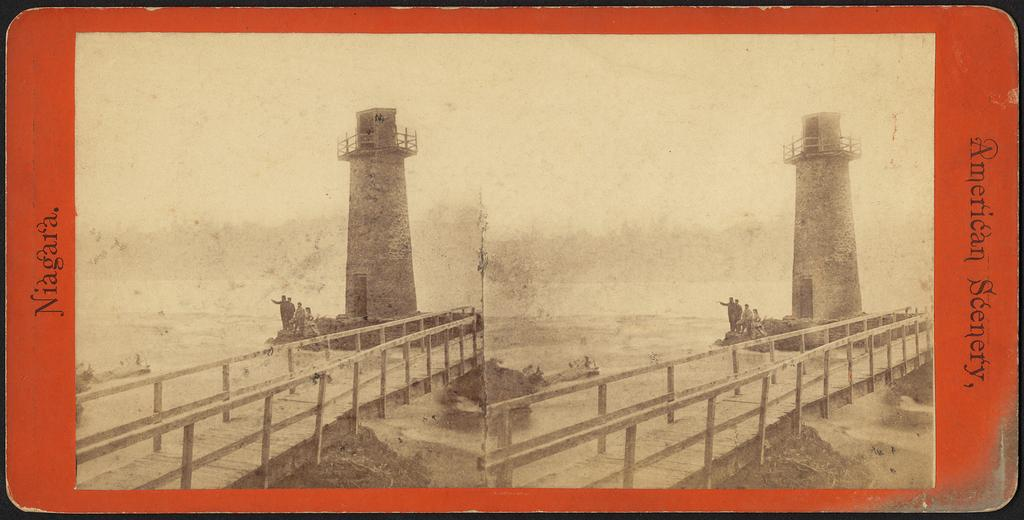<image>
Describe the image concisely. An old looking card has two lighthouses pictured on it from Niagara. 